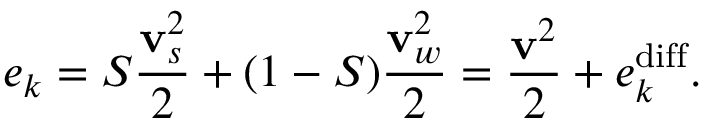<formula> <loc_0><loc_0><loc_500><loc_500>e _ { k } = S \frac { { v } _ { s } ^ { 2 } } { 2 } + ( 1 - S ) \frac { { v } _ { w } ^ { 2 } } { 2 } = \frac { { v } ^ { 2 } } { 2 } + e _ { k } ^ { d i f f } .</formula> 